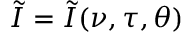Convert formula to latex. <formula><loc_0><loc_0><loc_500><loc_500>\tilde { I } = \tilde { I } ( \nu , \tau , \theta )</formula> 